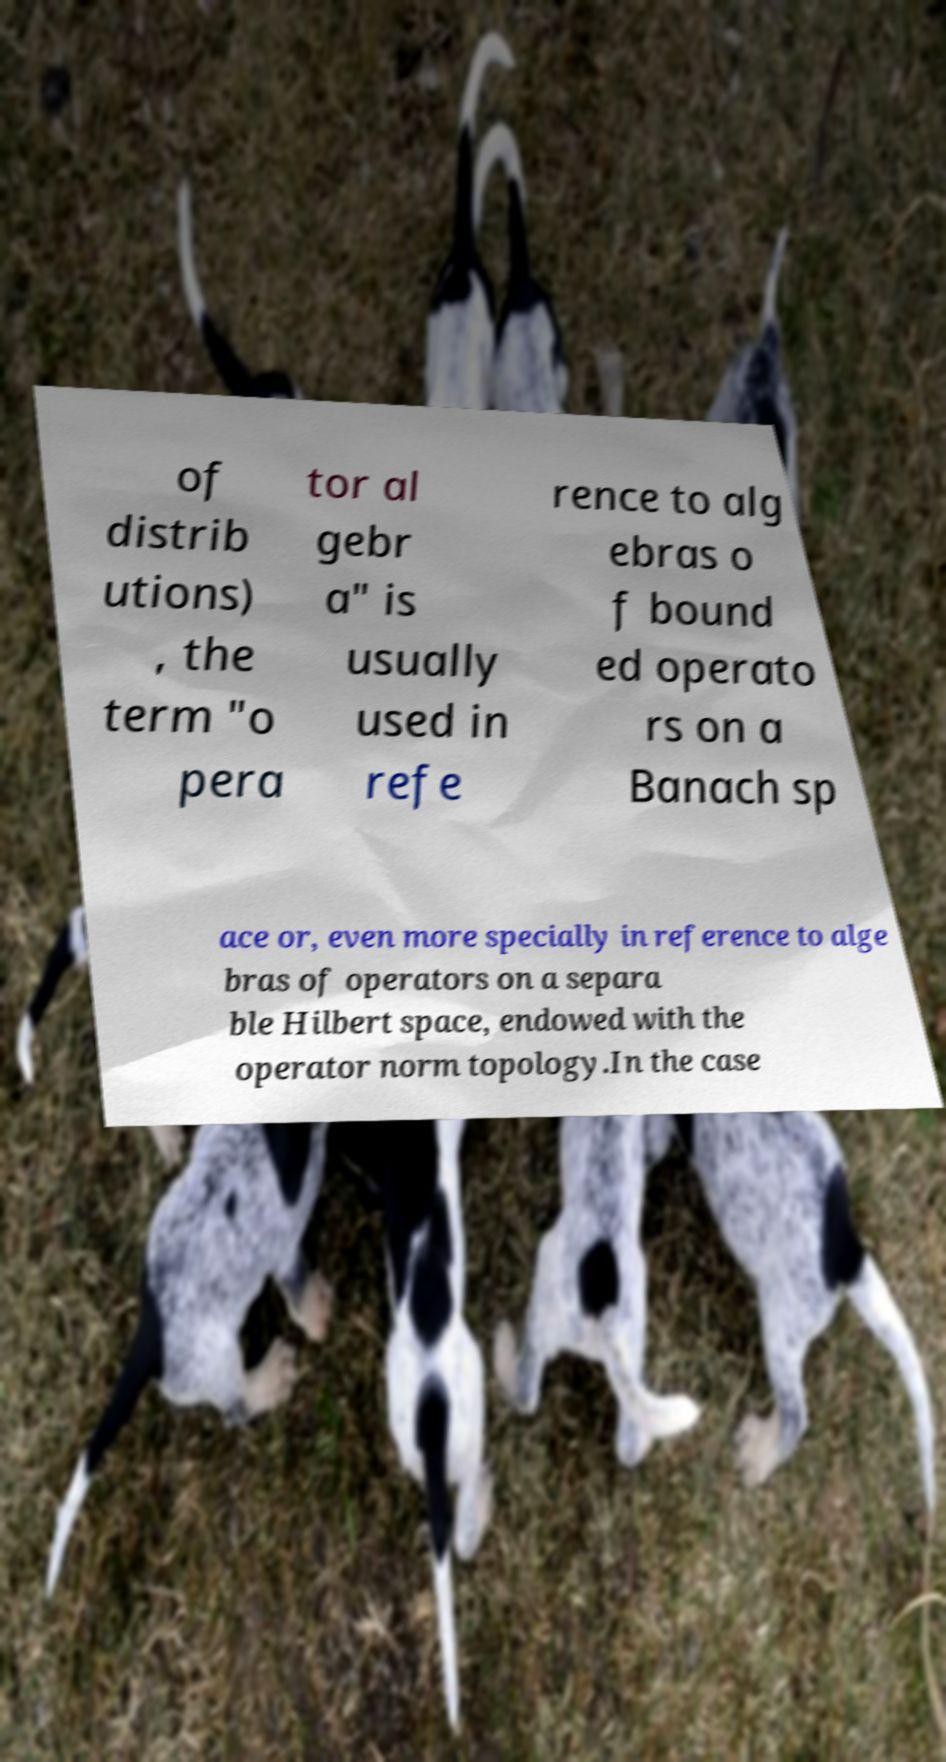Please identify and transcribe the text found in this image. of distrib utions) , the term "o pera tor al gebr a" is usually used in refe rence to alg ebras o f bound ed operato rs on a Banach sp ace or, even more specially in reference to alge bras of operators on a separa ble Hilbert space, endowed with the operator norm topology.In the case 